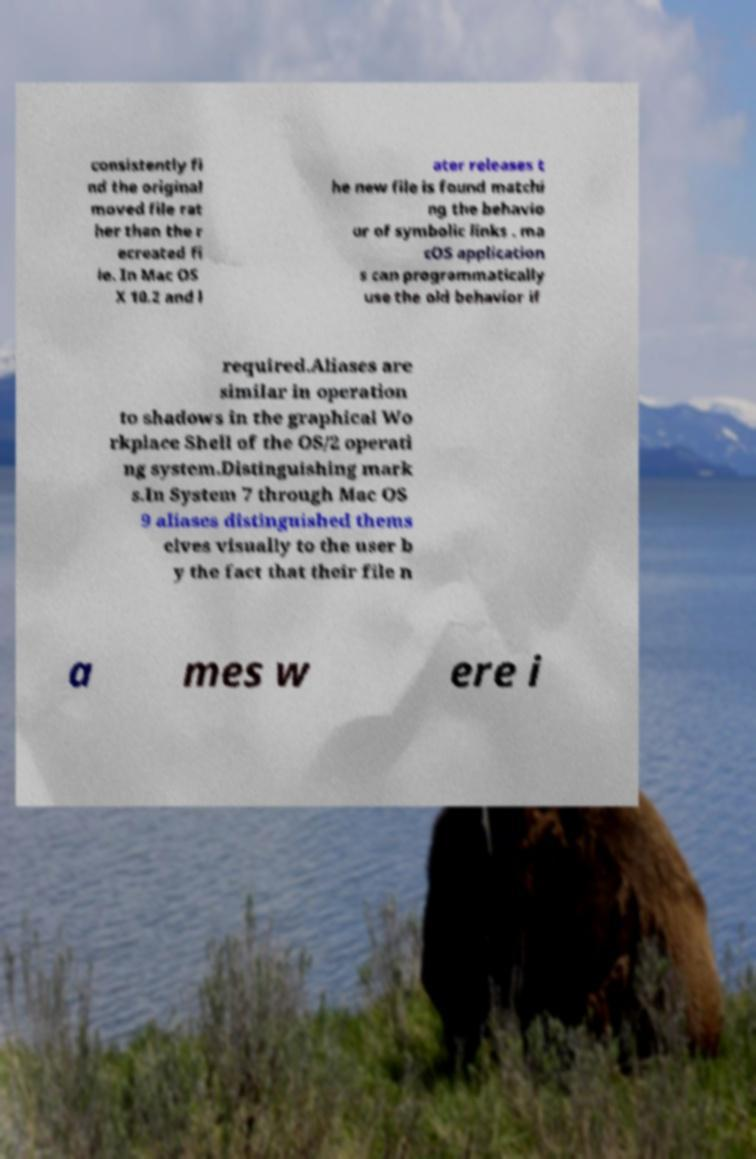For documentation purposes, I need the text within this image transcribed. Could you provide that? consistently fi nd the original moved file rat her than the r ecreated fi le. In Mac OS X 10.2 and l ater releases t he new file is found matchi ng the behavio ur of symbolic links . ma cOS application s can programmatically use the old behavior if required.Aliases are similar in operation to shadows in the graphical Wo rkplace Shell of the OS/2 operati ng system.Distinguishing mark s.In System 7 through Mac OS 9 aliases distinguished thems elves visually to the user b y the fact that their file n a mes w ere i 